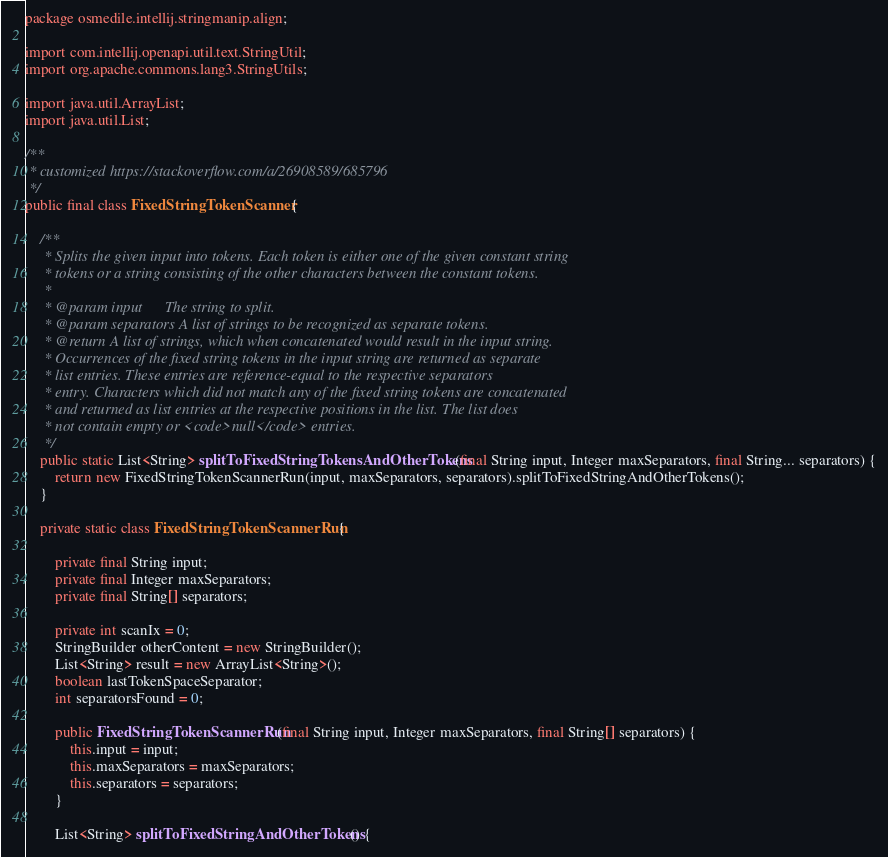Convert code to text. <code><loc_0><loc_0><loc_500><loc_500><_Java_>package osmedile.intellij.stringmanip.align;

import com.intellij.openapi.util.text.StringUtil;
import org.apache.commons.lang3.StringUtils;

import java.util.ArrayList;
import java.util.List;

/**
 * customized https://stackoverflow.com/a/26908589/685796
 */
public final class FixedStringTokenScanner {

	/**
	 * Splits the given input into tokens. Each token is either one of the given constant string
	 * tokens or a string consisting of the other characters between the constant tokens.
	 *
	 * @param input      The string to split.
	 * @param separators A list of strings to be recognized as separate tokens.
	 * @return A list of strings, which when concatenated would result in the input string.
	 * Occurrences of the fixed string tokens in the input string are returned as separate
	 * list entries. These entries are reference-equal to the respective separators
	 * entry. Characters which did not match any of the fixed string tokens are concatenated
	 * and returned as list entries at the respective positions in the list. The list does
	 * not contain empty or <code>null</code> entries.
	 */
	public static List<String> splitToFixedStringTokensAndOtherTokens(final String input, Integer maxSeparators, final String... separators) {
		return new FixedStringTokenScannerRun(input, maxSeparators, separators).splitToFixedStringAndOtherTokens();
	}

	private static class FixedStringTokenScannerRun {

		private final String input;
		private final Integer maxSeparators;
		private final String[] separators;

		private int scanIx = 0;
		StringBuilder otherContent = new StringBuilder();
		List<String> result = new ArrayList<String>();
		boolean lastTokenSpaceSeparator;
		int separatorsFound = 0;

		public FixedStringTokenScannerRun(final String input, Integer maxSeparators, final String[] separators) {
			this.input = input;
			this.maxSeparators = maxSeparators;
			this.separators = separators;
		}

		List<String> splitToFixedStringAndOtherTokens() {</code> 